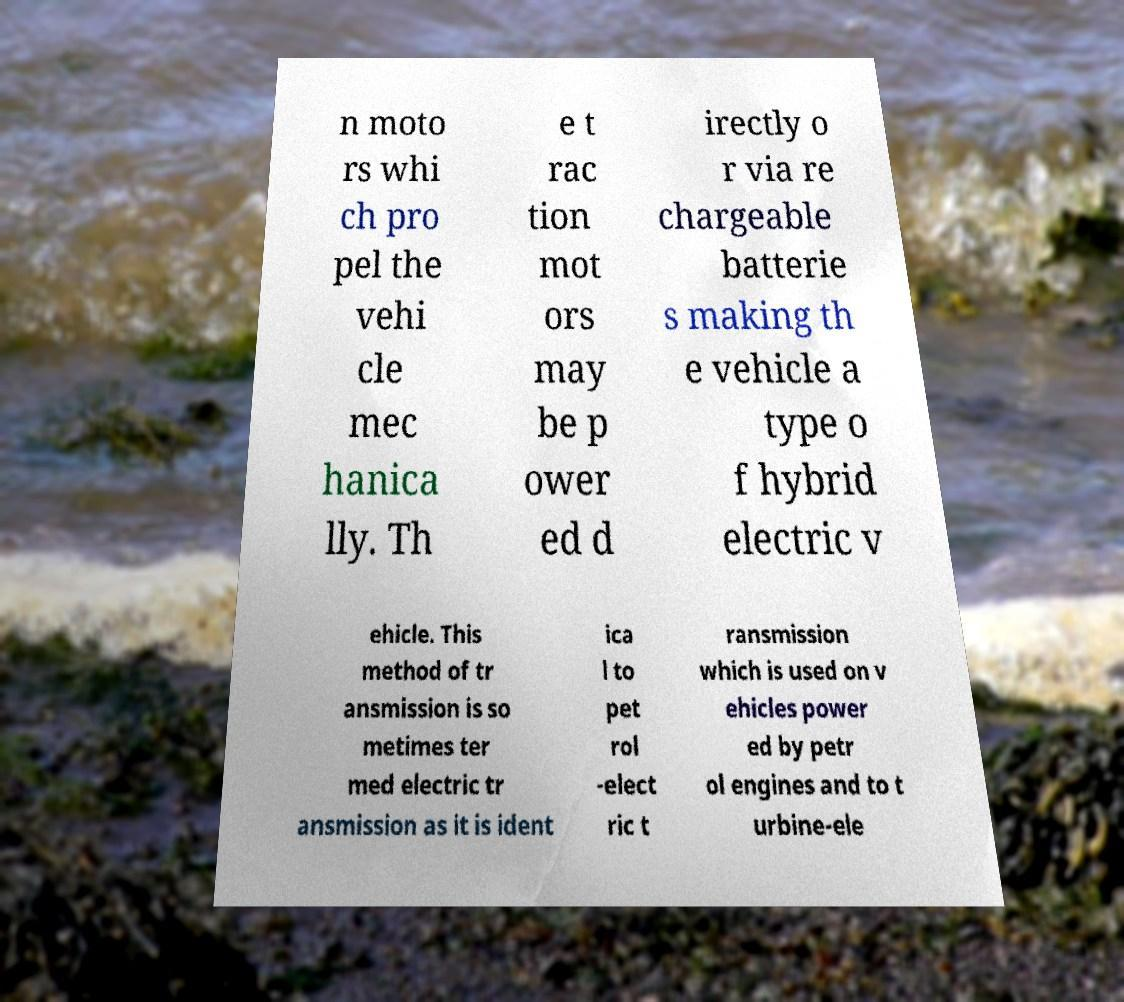Could you assist in decoding the text presented in this image and type it out clearly? n moto rs whi ch pro pel the vehi cle mec hanica lly. Th e t rac tion mot ors may be p ower ed d irectly o r via re chargeable batterie s making th e vehicle a type o f hybrid electric v ehicle. This method of tr ansmission is so metimes ter med electric tr ansmission as it is ident ica l to pet rol -elect ric t ransmission which is used on v ehicles power ed by petr ol engines and to t urbine-ele 